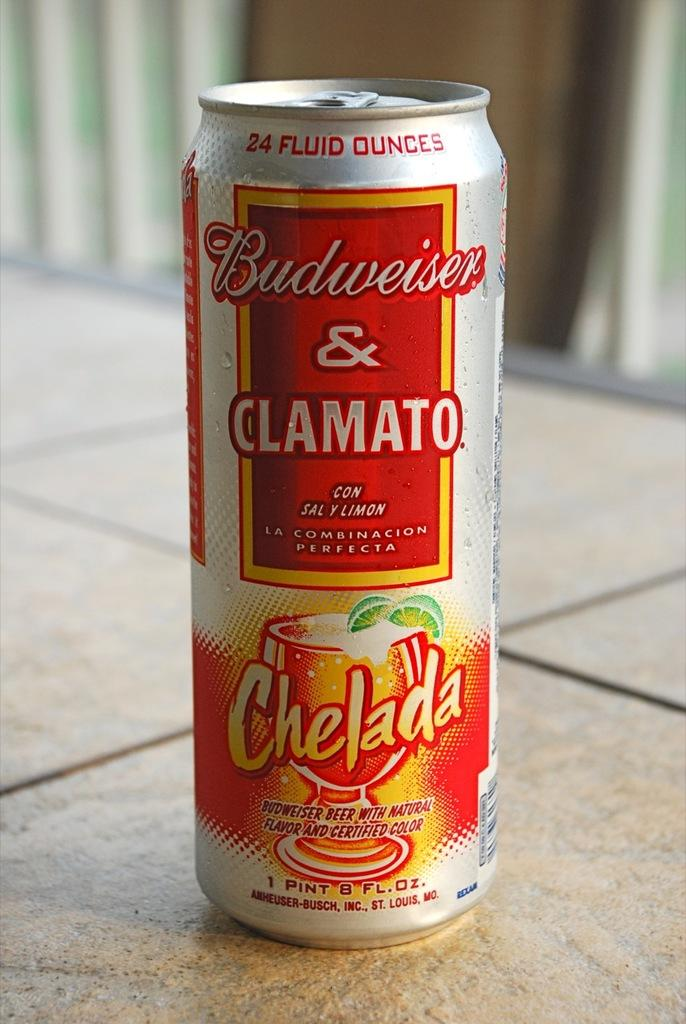<image>
Share a concise interpretation of the image provided. A can of Budweiser and Clamato called a Chelada. 